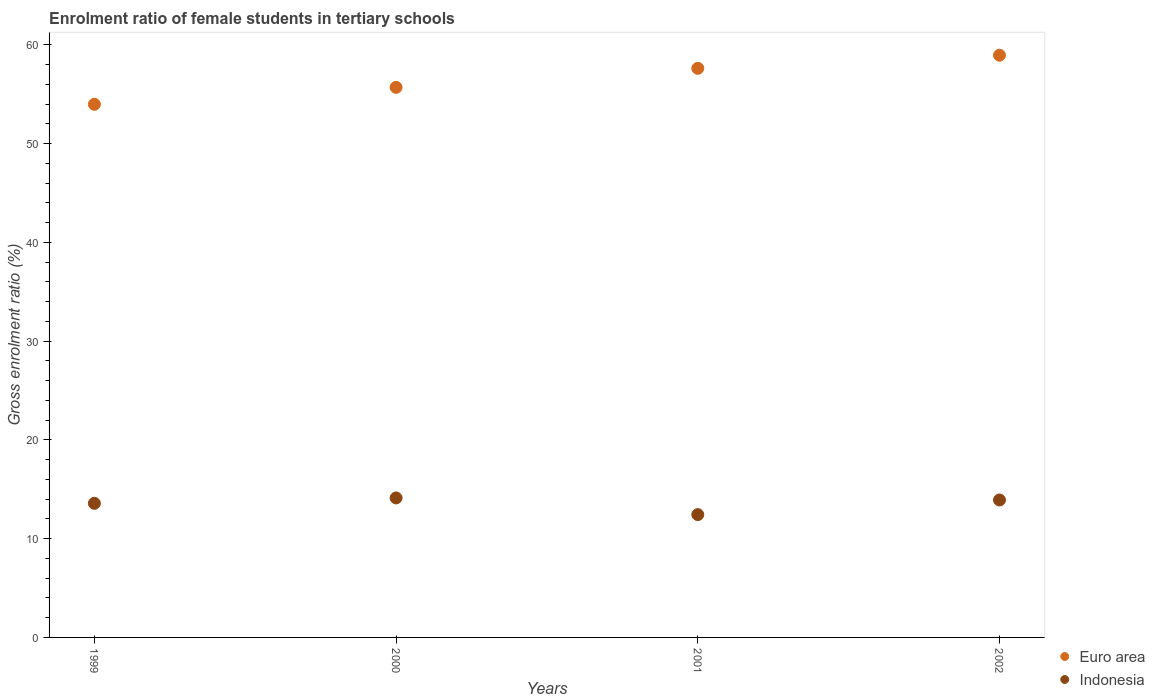How many different coloured dotlines are there?
Make the answer very short. 2. Is the number of dotlines equal to the number of legend labels?
Make the answer very short. Yes. What is the enrolment ratio of female students in tertiary schools in Euro area in 2000?
Your answer should be compact. 55.7. Across all years, what is the maximum enrolment ratio of female students in tertiary schools in Indonesia?
Give a very brief answer. 14.13. Across all years, what is the minimum enrolment ratio of female students in tertiary schools in Euro area?
Ensure brevity in your answer.  53.99. In which year was the enrolment ratio of female students in tertiary schools in Indonesia maximum?
Provide a short and direct response. 2000. What is the total enrolment ratio of female students in tertiary schools in Euro area in the graph?
Offer a terse response. 226.28. What is the difference between the enrolment ratio of female students in tertiary schools in Indonesia in 1999 and that in 2000?
Your answer should be compact. -0.55. What is the difference between the enrolment ratio of female students in tertiary schools in Indonesia in 2002 and the enrolment ratio of female students in tertiary schools in Euro area in 2001?
Your response must be concise. -43.71. What is the average enrolment ratio of female students in tertiary schools in Euro area per year?
Provide a succinct answer. 56.57. In the year 2000, what is the difference between the enrolment ratio of female students in tertiary schools in Euro area and enrolment ratio of female students in tertiary schools in Indonesia?
Give a very brief answer. 41.58. In how many years, is the enrolment ratio of female students in tertiary schools in Indonesia greater than 38 %?
Your response must be concise. 0. What is the ratio of the enrolment ratio of female students in tertiary schools in Indonesia in 1999 to that in 2000?
Ensure brevity in your answer.  0.96. What is the difference between the highest and the second highest enrolment ratio of female students in tertiary schools in Indonesia?
Your response must be concise. 0.21. What is the difference between the highest and the lowest enrolment ratio of female students in tertiary schools in Euro area?
Give a very brief answer. 4.97. Does the enrolment ratio of female students in tertiary schools in Euro area monotonically increase over the years?
Offer a very short reply. Yes. Is the enrolment ratio of female students in tertiary schools in Euro area strictly greater than the enrolment ratio of female students in tertiary schools in Indonesia over the years?
Ensure brevity in your answer.  Yes. Is the enrolment ratio of female students in tertiary schools in Euro area strictly less than the enrolment ratio of female students in tertiary schools in Indonesia over the years?
Your response must be concise. No. What is the difference between two consecutive major ticks on the Y-axis?
Ensure brevity in your answer.  10. Are the values on the major ticks of Y-axis written in scientific E-notation?
Provide a succinct answer. No. Does the graph contain any zero values?
Offer a very short reply. No. Does the graph contain grids?
Offer a very short reply. No. Where does the legend appear in the graph?
Give a very brief answer. Bottom right. What is the title of the graph?
Provide a succinct answer. Enrolment ratio of female students in tertiary schools. What is the Gross enrolment ratio (%) in Euro area in 1999?
Ensure brevity in your answer.  53.99. What is the Gross enrolment ratio (%) of Indonesia in 1999?
Offer a very short reply. 13.58. What is the Gross enrolment ratio (%) of Euro area in 2000?
Provide a short and direct response. 55.7. What is the Gross enrolment ratio (%) in Indonesia in 2000?
Offer a very short reply. 14.13. What is the Gross enrolment ratio (%) in Euro area in 2001?
Keep it short and to the point. 57.63. What is the Gross enrolment ratio (%) of Indonesia in 2001?
Offer a very short reply. 12.44. What is the Gross enrolment ratio (%) of Euro area in 2002?
Give a very brief answer. 58.96. What is the Gross enrolment ratio (%) in Indonesia in 2002?
Make the answer very short. 13.92. Across all years, what is the maximum Gross enrolment ratio (%) in Euro area?
Keep it short and to the point. 58.96. Across all years, what is the maximum Gross enrolment ratio (%) of Indonesia?
Ensure brevity in your answer.  14.13. Across all years, what is the minimum Gross enrolment ratio (%) of Euro area?
Offer a very short reply. 53.99. Across all years, what is the minimum Gross enrolment ratio (%) in Indonesia?
Your answer should be compact. 12.44. What is the total Gross enrolment ratio (%) in Euro area in the graph?
Keep it short and to the point. 226.28. What is the total Gross enrolment ratio (%) of Indonesia in the graph?
Your response must be concise. 54.06. What is the difference between the Gross enrolment ratio (%) in Euro area in 1999 and that in 2000?
Your answer should be compact. -1.71. What is the difference between the Gross enrolment ratio (%) of Indonesia in 1999 and that in 2000?
Provide a succinct answer. -0.55. What is the difference between the Gross enrolment ratio (%) of Euro area in 1999 and that in 2001?
Keep it short and to the point. -3.64. What is the difference between the Gross enrolment ratio (%) in Indonesia in 1999 and that in 2001?
Provide a short and direct response. 1.14. What is the difference between the Gross enrolment ratio (%) of Euro area in 1999 and that in 2002?
Make the answer very short. -4.97. What is the difference between the Gross enrolment ratio (%) in Indonesia in 1999 and that in 2002?
Provide a succinct answer. -0.34. What is the difference between the Gross enrolment ratio (%) of Euro area in 2000 and that in 2001?
Provide a succinct answer. -1.93. What is the difference between the Gross enrolment ratio (%) in Indonesia in 2000 and that in 2001?
Provide a short and direct response. 1.69. What is the difference between the Gross enrolment ratio (%) of Euro area in 2000 and that in 2002?
Your answer should be compact. -3.25. What is the difference between the Gross enrolment ratio (%) in Indonesia in 2000 and that in 2002?
Provide a short and direct response. 0.21. What is the difference between the Gross enrolment ratio (%) of Euro area in 2001 and that in 2002?
Make the answer very short. -1.33. What is the difference between the Gross enrolment ratio (%) in Indonesia in 2001 and that in 2002?
Give a very brief answer. -1.48. What is the difference between the Gross enrolment ratio (%) of Euro area in 1999 and the Gross enrolment ratio (%) of Indonesia in 2000?
Keep it short and to the point. 39.86. What is the difference between the Gross enrolment ratio (%) of Euro area in 1999 and the Gross enrolment ratio (%) of Indonesia in 2001?
Your answer should be compact. 41.55. What is the difference between the Gross enrolment ratio (%) in Euro area in 1999 and the Gross enrolment ratio (%) in Indonesia in 2002?
Make the answer very short. 40.07. What is the difference between the Gross enrolment ratio (%) in Euro area in 2000 and the Gross enrolment ratio (%) in Indonesia in 2001?
Make the answer very short. 43.27. What is the difference between the Gross enrolment ratio (%) in Euro area in 2000 and the Gross enrolment ratio (%) in Indonesia in 2002?
Give a very brief answer. 41.79. What is the difference between the Gross enrolment ratio (%) of Euro area in 2001 and the Gross enrolment ratio (%) of Indonesia in 2002?
Keep it short and to the point. 43.71. What is the average Gross enrolment ratio (%) in Euro area per year?
Provide a short and direct response. 56.57. What is the average Gross enrolment ratio (%) of Indonesia per year?
Your response must be concise. 13.52. In the year 1999, what is the difference between the Gross enrolment ratio (%) in Euro area and Gross enrolment ratio (%) in Indonesia?
Give a very brief answer. 40.41. In the year 2000, what is the difference between the Gross enrolment ratio (%) in Euro area and Gross enrolment ratio (%) in Indonesia?
Ensure brevity in your answer.  41.58. In the year 2001, what is the difference between the Gross enrolment ratio (%) of Euro area and Gross enrolment ratio (%) of Indonesia?
Provide a succinct answer. 45.19. In the year 2002, what is the difference between the Gross enrolment ratio (%) of Euro area and Gross enrolment ratio (%) of Indonesia?
Your answer should be very brief. 45.04. What is the ratio of the Gross enrolment ratio (%) in Euro area in 1999 to that in 2000?
Offer a terse response. 0.97. What is the ratio of the Gross enrolment ratio (%) in Indonesia in 1999 to that in 2000?
Provide a succinct answer. 0.96. What is the ratio of the Gross enrolment ratio (%) of Euro area in 1999 to that in 2001?
Offer a terse response. 0.94. What is the ratio of the Gross enrolment ratio (%) of Indonesia in 1999 to that in 2001?
Your answer should be very brief. 1.09. What is the ratio of the Gross enrolment ratio (%) of Euro area in 1999 to that in 2002?
Your answer should be compact. 0.92. What is the ratio of the Gross enrolment ratio (%) of Indonesia in 1999 to that in 2002?
Provide a short and direct response. 0.98. What is the ratio of the Gross enrolment ratio (%) of Euro area in 2000 to that in 2001?
Offer a terse response. 0.97. What is the ratio of the Gross enrolment ratio (%) of Indonesia in 2000 to that in 2001?
Your answer should be compact. 1.14. What is the ratio of the Gross enrolment ratio (%) in Euro area in 2000 to that in 2002?
Make the answer very short. 0.94. What is the ratio of the Gross enrolment ratio (%) in Euro area in 2001 to that in 2002?
Offer a terse response. 0.98. What is the ratio of the Gross enrolment ratio (%) in Indonesia in 2001 to that in 2002?
Ensure brevity in your answer.  0.89. What is the difference between the highest and the second highest Gross enrolment ratio (%) in Euro area?
Keep it short and to the point. 1.33. What is the difference between the highest and the second highest Gross enrolment ratio (%) of Indonesia?
Offer a very short reply. 0.21. What is the difference between the highest and the lowest Gross enrolment ratio (%) in Euro area?
Keep it short and to the point. 4.97. What is the difference between the highest and the lowest Gross enrolment ratio (%) in Indonesia?
Provide a short and direct response. 1.69. 